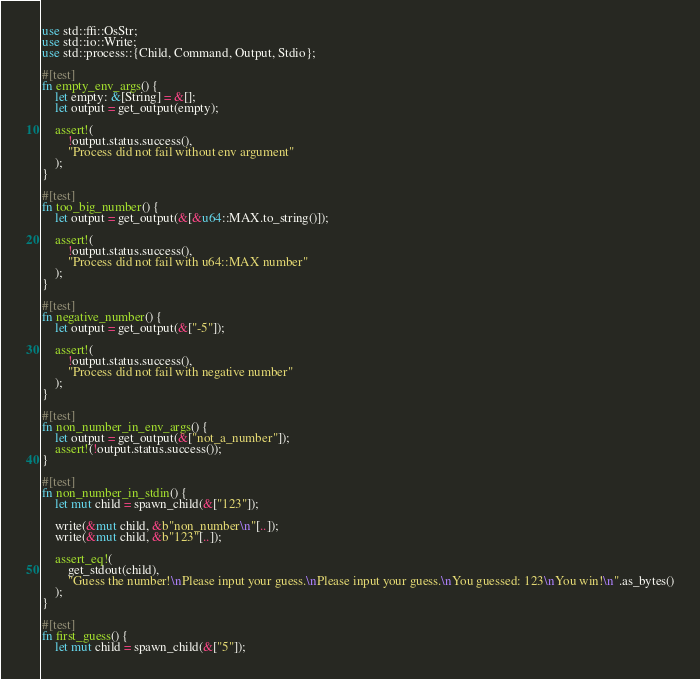Convert code to text. <code><loc_0><loc_0><loc_500><loc_500><_Rust_>use std::ffi::OsStr;
use std::io::Write;
use std::process::{Child, Command, Output, Stdio};

#[test]
fn empty_env_args() {
    let empty: &[String] = &[];
    let output = get_output(empty);

    assert!(
        !output.status.success(),
        "Process did not fail without env argument"
    );
}

#[test]
fn too_big_number() {
    let output = get_output(&[&u64::MAX.to_string()]);

    assert!(
        !output.status.success(),
        "Process did not fail with u64::MAX number"
    );
}

#[test]
fn negative_number() {
    let output = get_output(&["-5"]);

    assert!(
        !output.status.success(),
        "Process did not fail with negative number"
    );
}

#[test]
fn non_number_in_env_args() {
    let output = get_output(&["not_a_number"]);
    assert!(!output.status.success());
}

#[test]
fn non_number_in_stdin() {
    let mut child = spawn_child(&["123"]);

    write(&mut child, &b"non_number\n"[..]);
    write(&mut child, &b"123"[..]);

    assert_eq!(
        get_stdout(child),
        "Guess the number!\nPlease input your guess.\nPlease input your guess.\nYou guessed: 123\nYou win!\n".as_bytes()
    );
}

#[test]
fn first_guess() {
    let mut child = spawn_child(&["5"]);
</code> 